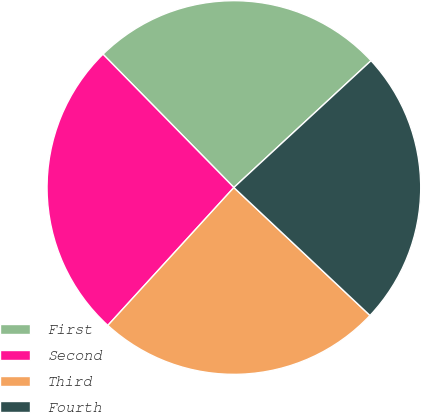Convert chart. <chart><loc_0><loc_0><loc_500><loc_500><pie_chart><fcel>First<fcel>Second<fcel>Third<fcel>Fourth<nl><fcel>25.48%<fcel>25.86%<fcel>24.78%<fcel>23.89%<nl></chart> 